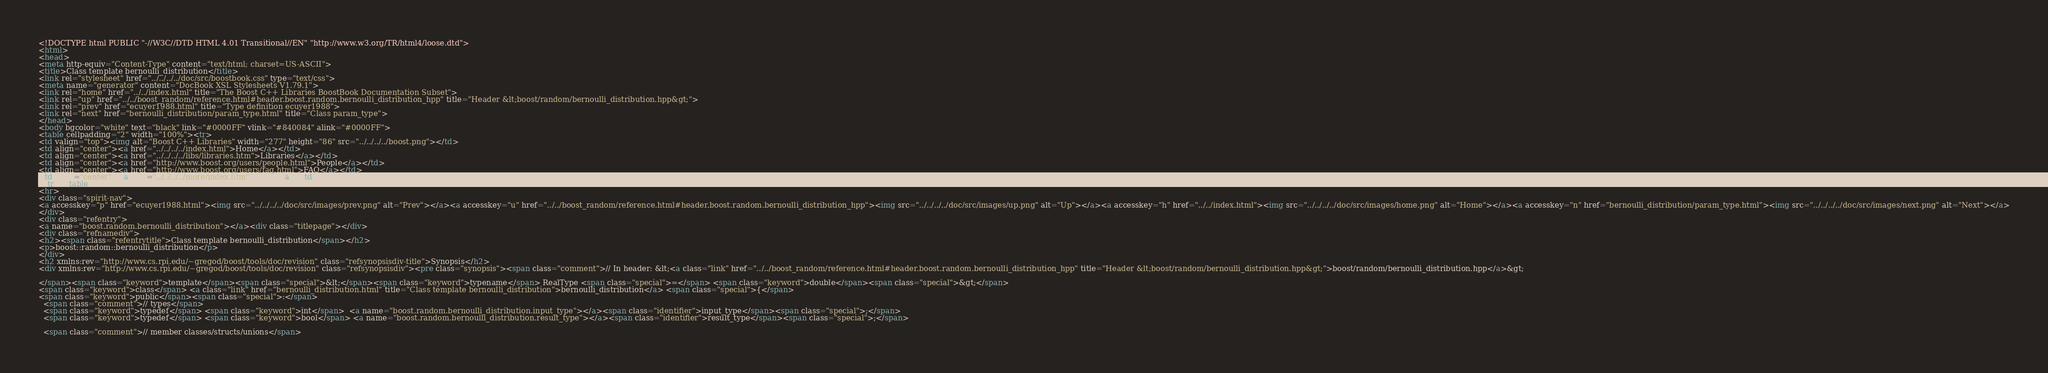Convert code to text. <code><loc_0><loc_0><loc_500><loc_500><_HTML_><!DOCTYPE html PUBLIC "-//W3C//DTD HTML 4.01 Transitional//EN" "http://www.w3.org/TR/html4/loose.dtd">
<html>
<head>
<meta http-equiv="Content-Type" content="text/html; charset=US-ASCII">
<title>Class template bernoulli_distribution</title>
<link rel="stylesheet" href="../../../../doc/src/boostbook.css" type="text/css">
<meta name="generator" content="DocBook XSL Stylesheets V1.79.1">
<link rel="home" href="../../index.html" title="The Boost C++ Libraries BoostBook Documentation Subset">
<link rel="up" href="../../boost_random/reference.html#header.boost.random.bernoulli_distribution_hpp" title="Header &lt;boost/random/bernoulli_distribution.hpp&gt;">
<link rel="prev" href="ecuyer1988.html" title="Type definition ecuyer1988">
<link rel="next" href="bernoulli_distribution/param_type.html" title="Class param_type">
</head>
<body bgcolor="white" text="black" link="#0000FF" vlink="#840084" alink="#0000FF">
<table cellpadding="2" width="100%"><tr>
<td valign="top"><img alt="Boost C++ Libraries" width="277" height="86" src="../../../../boost.png"></td>
<td align="center"><a href="../../../../index.html">Home</a></td>
<td align="center"><a href="../../../../libs/libraries.htm">Libraries</a></td>
<td align="center"><a href="http://www.boost.org/users/people.html">People</a></td>
<td align="center"><a href="http://www.boost.org/users/faq.html">FAQ</a></td>
<td align="center"><a href="../../../../more/index.htm">More</a></td>
</tr></table>
<hr>
<div class="spirit-nav">
<a accesskey="p" href="ecuyer1988.html"><img src="../../../../doc/src/images/prev.png" alt="Prev"></a><a accesskey="u" href="../../boost_random/reference.html#header.boost.random.bernoulli_distribution_hpp"><img src="../../../../doc/src/images/up.png" alt="Up"></a><a accesskey="h" href="../../index.html"><img src="../../../../doc/src/images/home.png" alt="Home"></a><a accesskey="n" href="bernoulli_distribution/param_type.html"><img src="../../../../doc/src/images/next.png" alt="Next"></a>
</div>
<div class="refentry">
<a name="boost.random.bernoulli_distribution"></a><div class="titlepage"></div>
<div class="refnamediv">
<h2><span class="refentrytitle">Class template bernoulli_distribution</span></h2>
<p>boost::random::bernoulli_distribution</p>
</div>
<h2 xmlns:rev="http://www.cs.rpi.edu/~gregod/boost/tools/doc/revision" class="refsynopsisdiv-title">Synopsis</h2>
<div xmlns:rev="http://www.cs.rpi.edu/~gregod/boost/tools/doc/revision" class="refsynopsisdiv"><pre class="synopsis"><span class="comment">// In header: &lt;<a class="link" href="../../boost_random/reference.html#header.boost.random.bernoulli_distribution_hpp" title="Header &lt;boost/random/bernoulli_distribution.hpp&gt;">boost/random/bernoulli_distribution.hpp</a>&gt;

</span><span class="keyword">template</span><span class="special">&lt;</span><span class="keyword">typename</span> RealType <span class="special">=</span> <span class="keyword">double</span><span class="special">&gt;</span> 
<span class="keyword">class</span> <a class="link" href="bernoulli_distribution.html" title="Class template bernoulli_distribution">bernoulli_distribution</a> <span class="special">{</span>
<span class="keyword">public</span><span class="special">:</span>
  <span class="comment">// types</span>
  <span class="keyword">typedef</span> <span class="keyword">int</span>  <a name="boost.random.bernoulli_distribution.input_type"></a><span class="identifier">input_type</span><span class="special">;</span> 
  <span class="keyword">typedef</span> <span class="keyword">bool</span> <a name="boost.random.bernoulli_distribution.result_type"></a><span class="identifier">result_type</span><span class="special">;</span>

  <span class="comment">// member classes/structs/unions</span>
</code> 